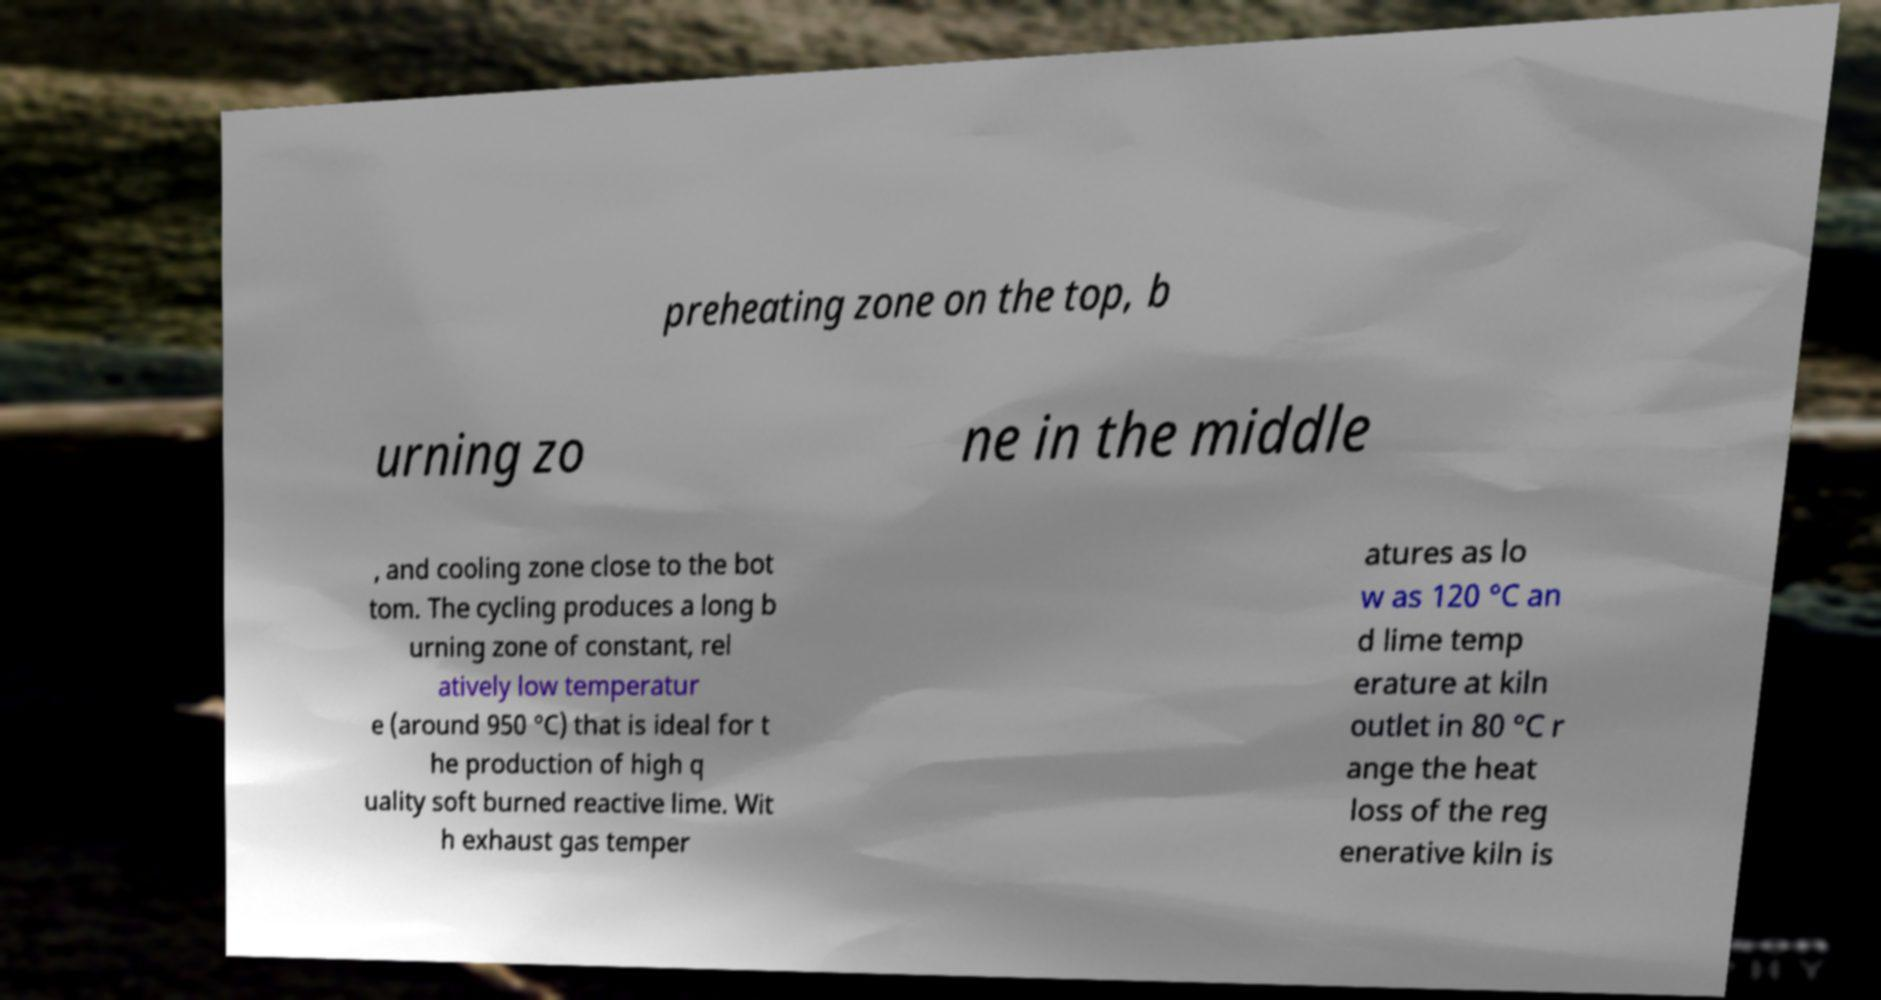I need the written content from this picture converted into text. Can you do that? preheating zone on the top, b urning zo ne in the middle , and cooling zone close to the bot tom. The cycling produces a long b urning zone of constant, rel atively low temperatur e (around 950 °C) that is ideal for t he production of high q uality soft burned reactive lime. Wit h exhaust gas temper atures as lo w as 120 °C an d lime temp erature at kiln outlet in 80 °C r ange the heat loss of the reg enerative kiln is 